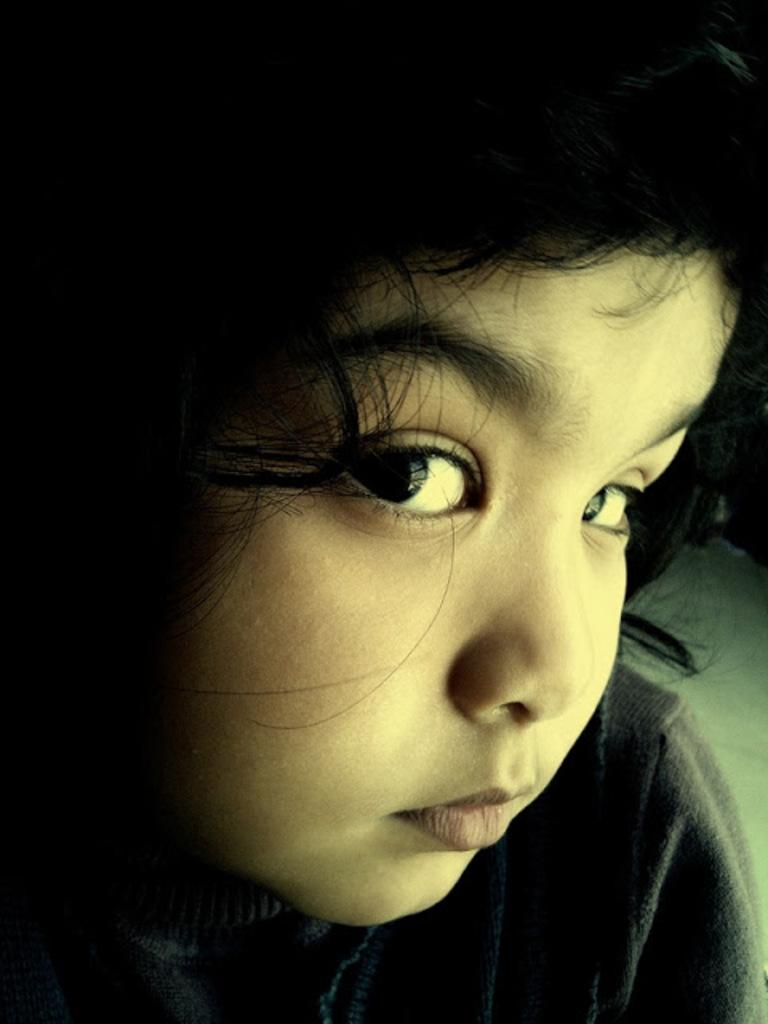What is the main subject of the image? There is a child in the image. What can be observed about the background of the image? The background of the image is dark. What is the child's profit from the stage performance in the image? There is no stage or performance mentioned in the image, and therefore no profit can be determined. 